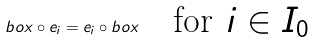<formula> <loc_0><loc_0><loc_500><loc_500>b o x \circ e _ { i } = e _ { i } \circ b o x \quad \text {for $i\in I_{0}$}</formula> 